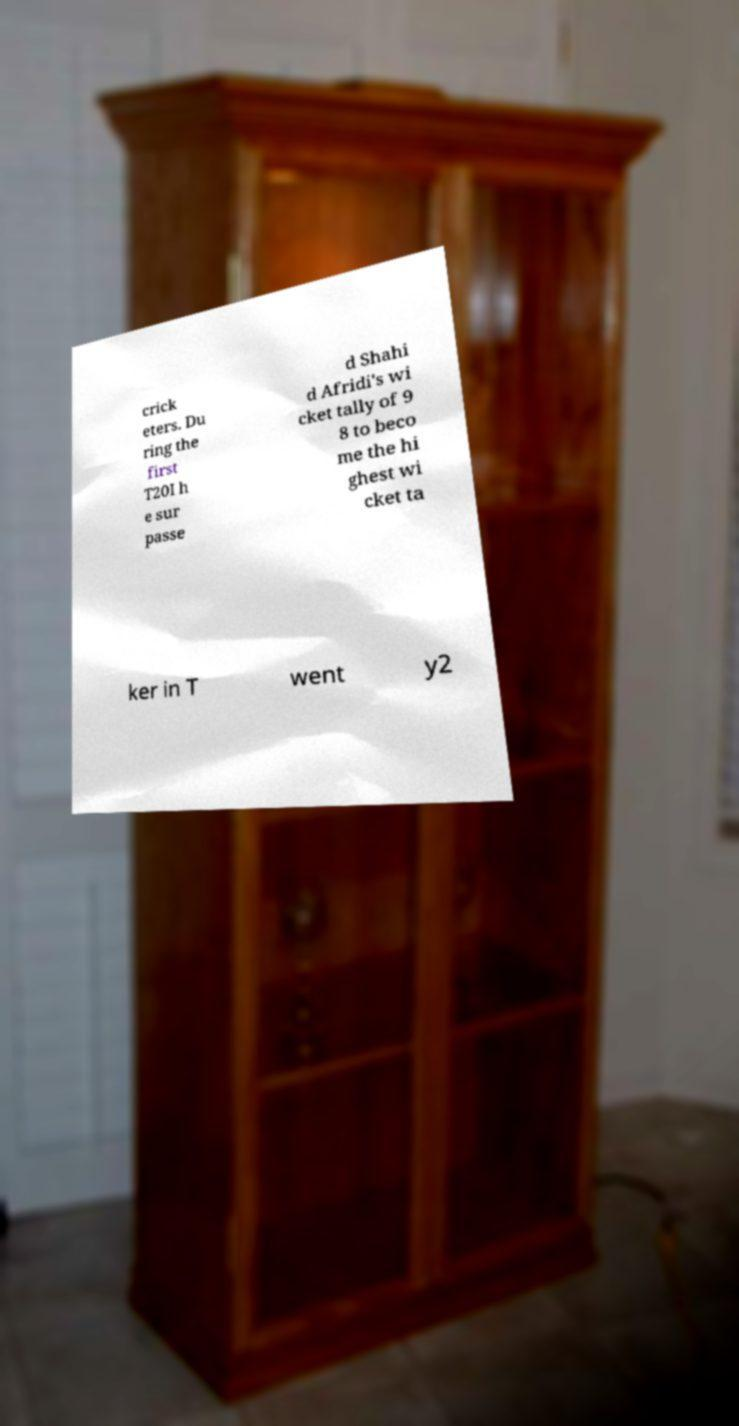Please read and relay the text visible in this image. What does it say? crick eters. Du ring the first T20I h e sur passe d Shahi d Afridi's wi cket tally of 9 8 to beco me the hi ghest wi cket ta ker in T went y2 